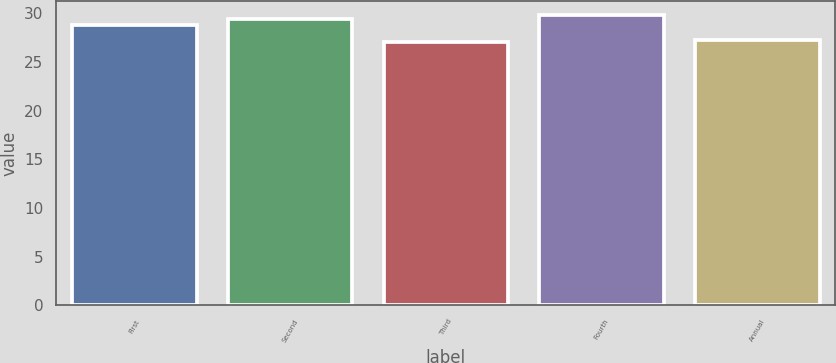<chart> <loc_0><loc_0><loc_500><loc_500><bar_chart><fcel>First<fcel>Second<fcel>Third<fcel>Fourth<fcel>Annual<nl><fcel>28.83<fcel>29.39<fcel>27<fcel>29.82<fcel>27.28<nl></chart> 